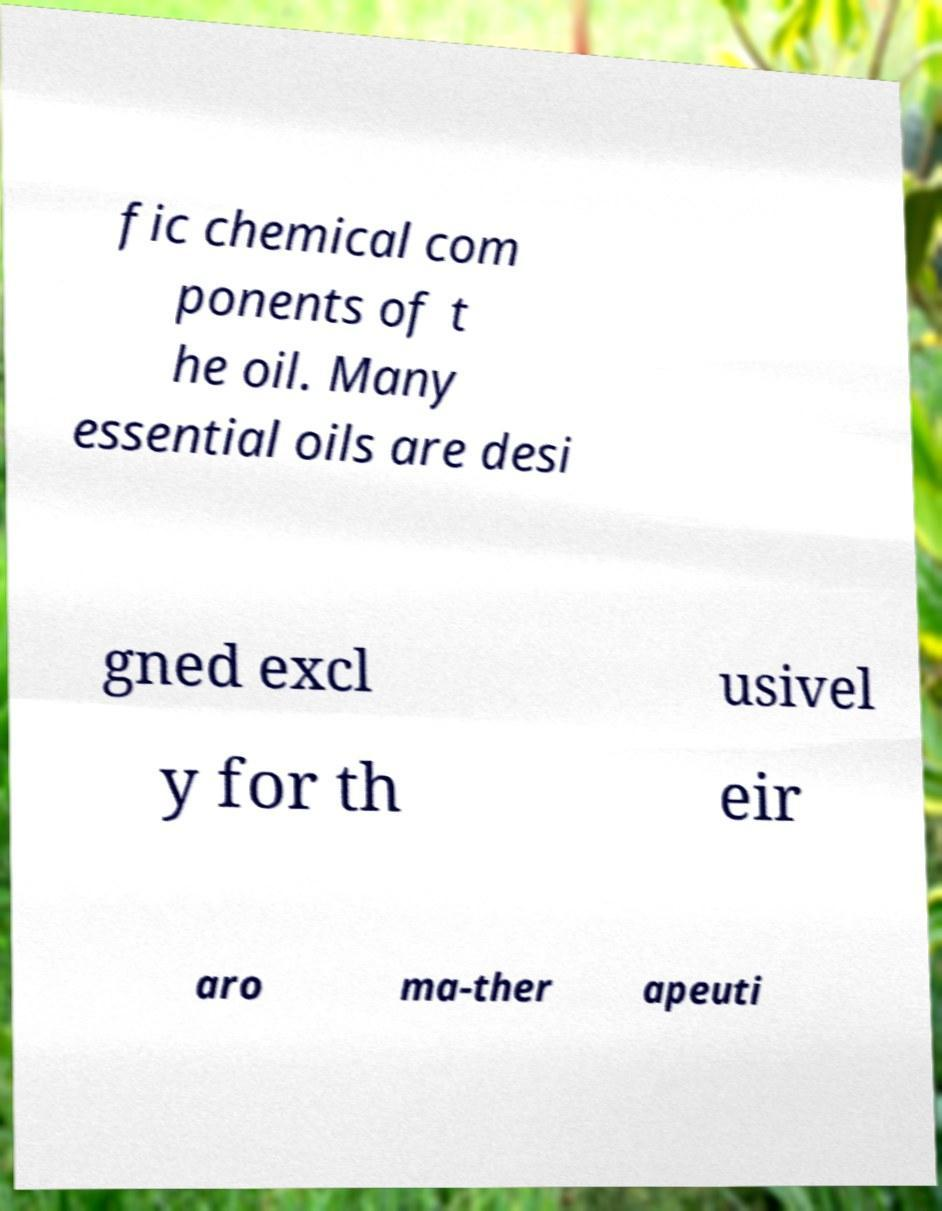Please read and relay the text visible in this image. What does it say? fic chemical com ponents of t he oil. Many essential oils are desi gned excl usivel y for th eir aro ma-ther apeuti 